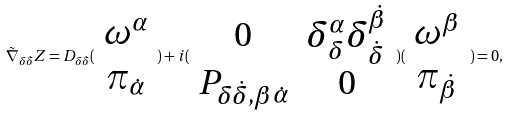Convert formula to latex. <formula><loc_0><loc_0><loc_500><loc_500>\tilde { \nabla } _ { \delta \dot { \delta } } Z = D _ { \delta \dot { \delta } } ( \begin{array} { c } \omega ^ { \alpha } \\ \pi _ { \dot { \alpha } } \end{array} ) + i ( \begin{array} { c c } 0 & \delta _ { \delta } ^ { \alpha } \delta _ { \dot { \delta } } ^ { \dot { \beta } } \\ P _ { \delta \dot { \delta } , \beta \dot { \alpha } } & 0 \end{array} ) ( \begin{array} { c } \omega ^ { \beta } \\ \pi _ { \dot { \beta } } \end{array} ) = 0 ,</formula> 